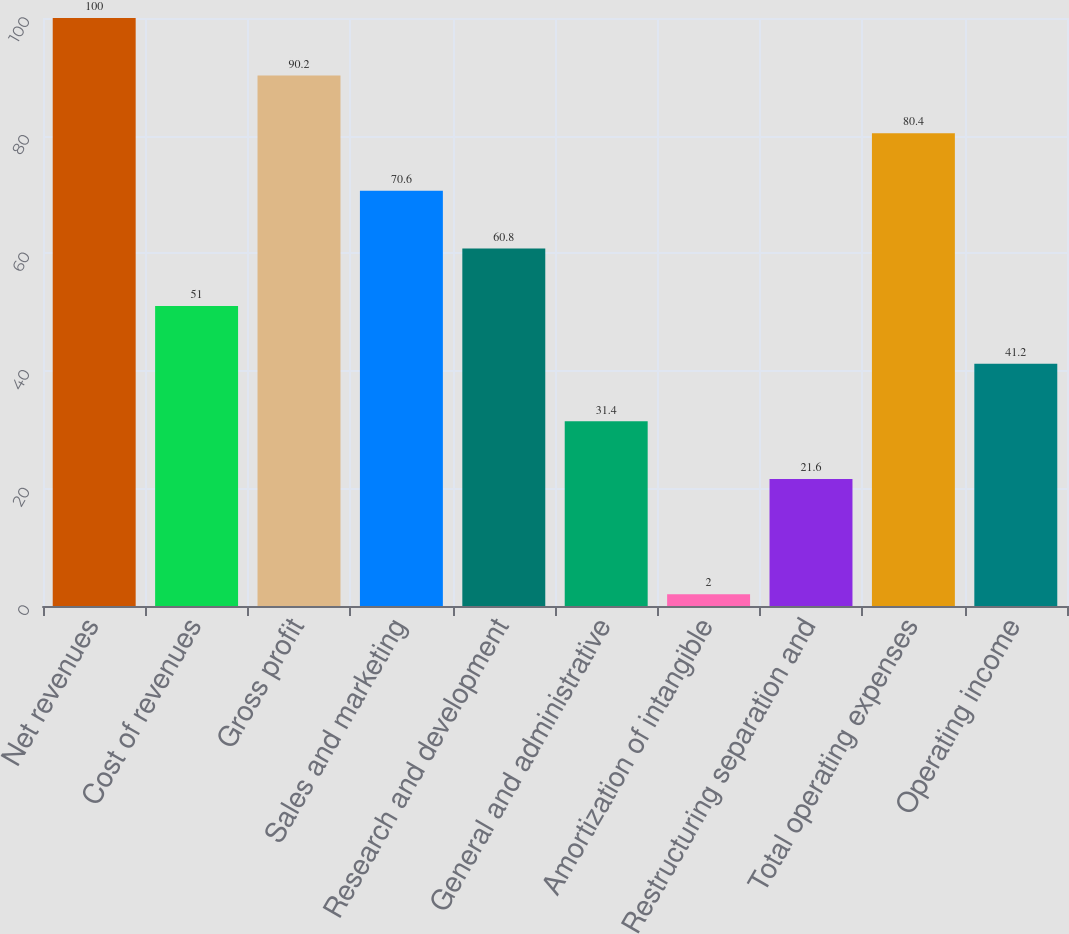<chart> <loc_0><loc_0><loc_500><loc_500><bar_chart><fcel>Net revenues<fcel>Cost of revenues<fcel>Gross profit<fcel>Sales and marketing<fcel>Research and development<fcel>General and administrative<fcel>Amortization of intangible<fcel>Restructuring separation and<fcel>Total operating expenses<fcel>Operating income<nl><fcel>100<fcel>51<fcel>90.2<fcel>70.6<fcel>60.8<fcel>31.4<fcel>2<fcel>21.6<fcel>80.4<fcel>41.2<nl></chart> 